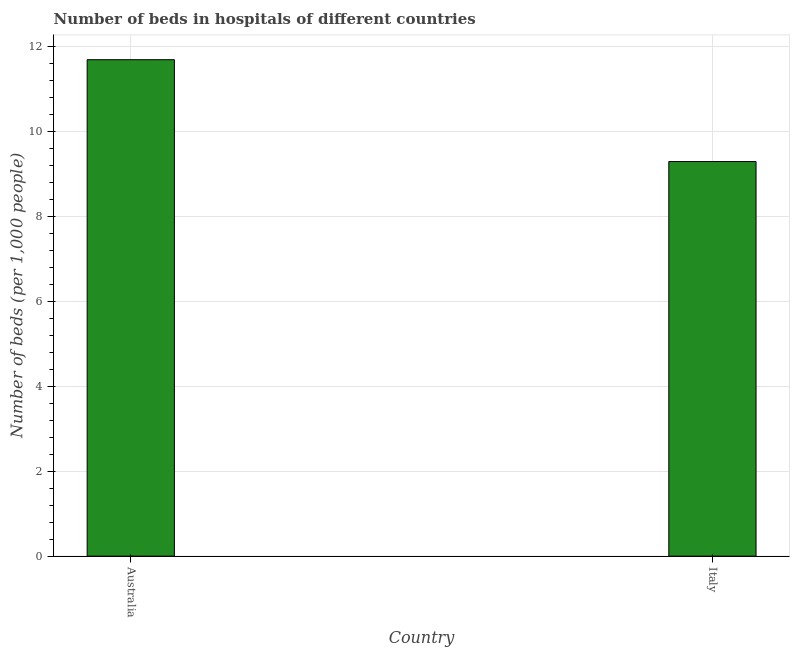Does the graph contain grids?
Offer a terse response. Yes. What is the title of the graph?
Provide a short and direct response. Number of beds in hospitals of different countries. What is the label or title of the Y-axis?
Your response must be concise. Number of beds (per 1,0 people). What is the number of hospital beds in Australia?
Ensure brevity in your answer.  11.7. Across all countries, what is the maximum number of hospital beds?
Make the answer very short. 11.7. Across all countries, what is the minimum number of hospital beds?
Your response must be concise. 9.3. In which country was the number of hospital beds minimum?
Your response must be concise. Italy. What is the sum of the number of hospital beds?
Your answer should be compact. 21. What is the average number of hospital beds per country?
Give a very brief answer. 10.5. What is the median number of hospital beds?
Your response must be concise. 10.5. What is the ratio of the number of hospital beds in Australia to that in Italy?
Provide a short and direct response. 1.26. Is the number of hospital beds in Australia less than that in Italy?
Your answer should be very brief. No. How many bars are there?
Your response must be concise. 2. Are all the bars in the graph horizontal?
Ensure brevity in your answer.  No. What is the difference between two consecutive major ticks on the Y-axis?
Your response must be concise. 2. What is the Number of beds (per 1,000 people) of Australia?
Your response must be concise. 11.7. What is the Number of beds (per 1,000 people) of Italy?
Your answer should be compact. 9.3. What is the ratio of the Number of beds (per 1,000 people) in Australia to that in Italy?
Your answer should be compact. 1.26. 